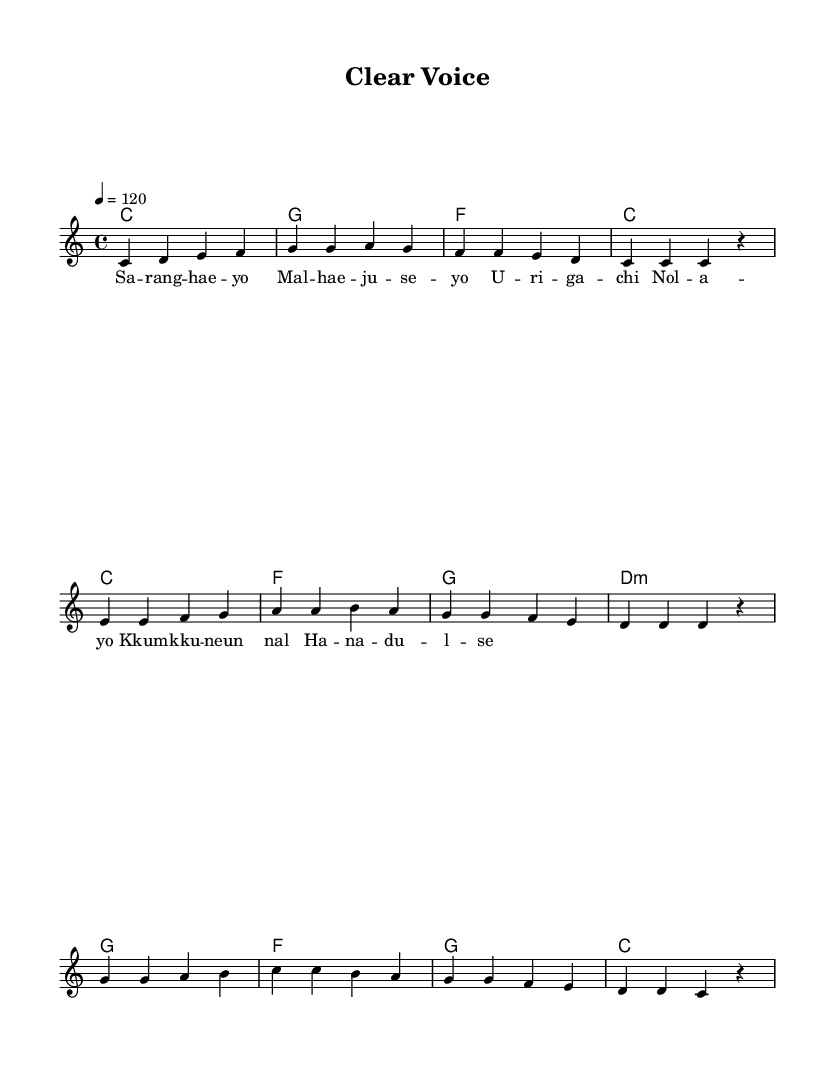What is the key signature of this music? The key signature is C major, which has no sharps or flats.
Answer: C major What is the time signature of this music? The time signature is indicated by the fraction at the beginning, showing four beats per measure.
Answer: 4/4 What is the tempo of the piece? The tempo is marked with a quarter note equaling 120 beats per minute.
Answer: 120 How many measures are in the melody section? By counting the groups of vertical lines (bar lines) in the melody, we can determine the number of measures, which is 8.
Answer: 8 What is the first note of the melody? The first note is found at the beginning of the melody, which is a C.
Answer: C What type of chord is the second chord in the harmonies? The second chord in the harmonies is a G major chord as indicated by the letter.
Answer: G Which word represents the end of the first phrase in the lyrics? The lyrics indicate a break after the word "yo," marking the end of the first phrase.
Answer: yo 